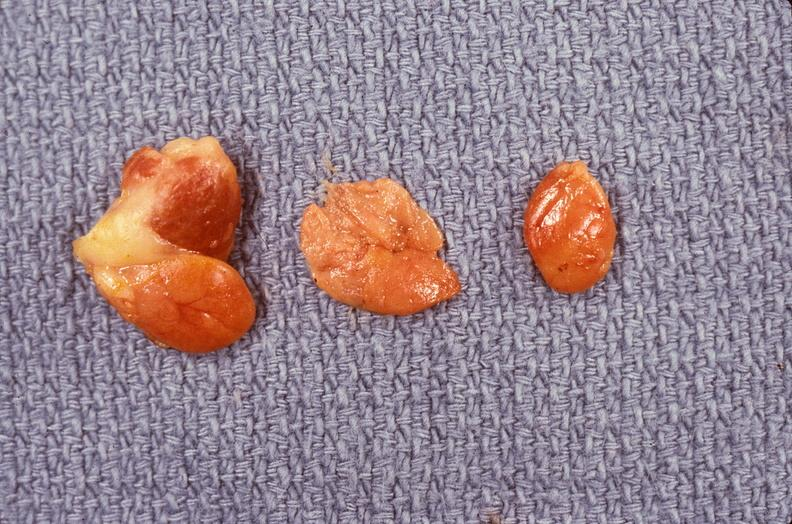does this image show parathyroid hyperplasia?
Answer the question using a single word or phrase. Yes 